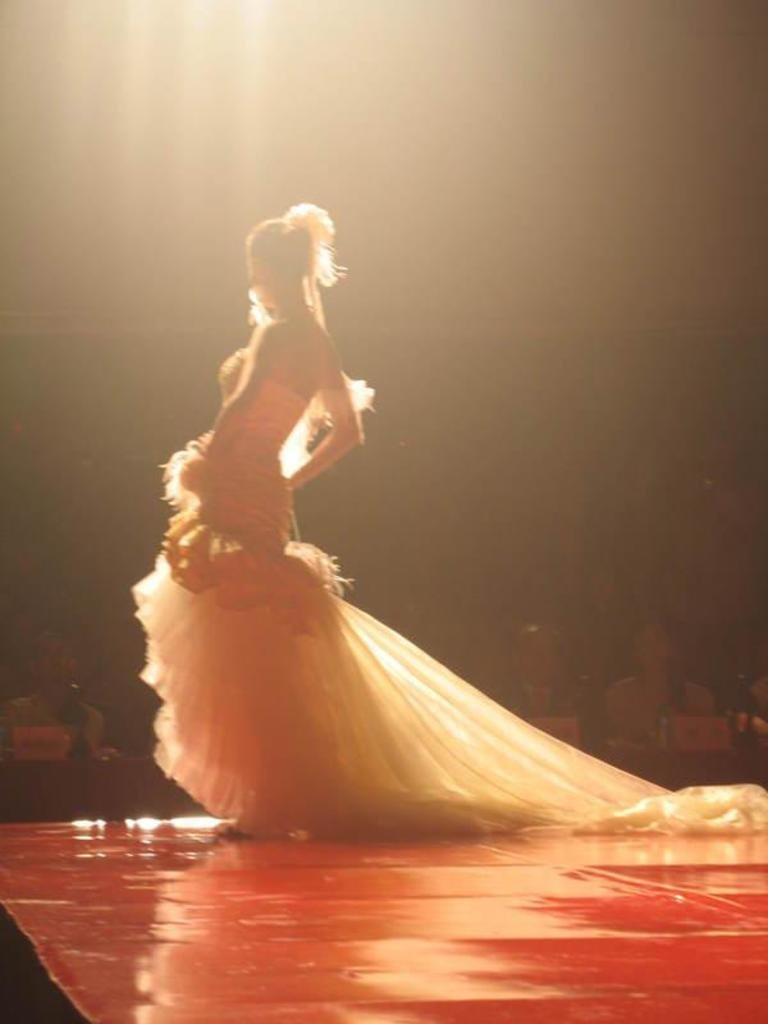Who is the main subject in the image? There is a lady standing in the center of the image. What is the lady wearing? The lady is wearing a costume. What can be seen in the background of the image? There are people and lights visible in the background of the image. What type of food is the lady holding in the image? There is no food visible in the image; the lady is wearing a costume and standing in the center. What is the purpose of the costume in the image? The purpose of the costume cannot be determined from the image alone, as it may be for a performance, event, or personal preference. 